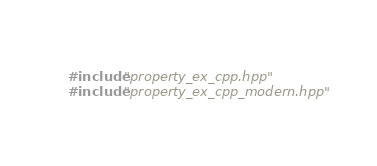Convert code to text. <code><loc_0><loc_0><loc_500><loc_500><_C++_>#include "property_ex_cpp.hpp"
#include "property_ex_cpp_modern.hpp"
</code> 